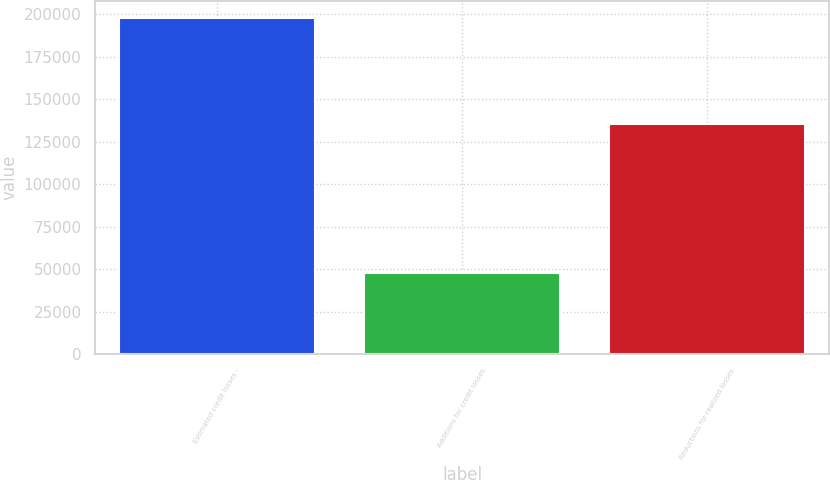Convert chart to OTSL. <chart><loc_0><loc_0><loc_500><loc_500><bar_chart><fcel>Estimated credit losses -<fcel>Additions for credit losses<fcel>Reductions for realized losses<nl><fcel>197809<fcel>47822<fcel>135412<nl></chart> 